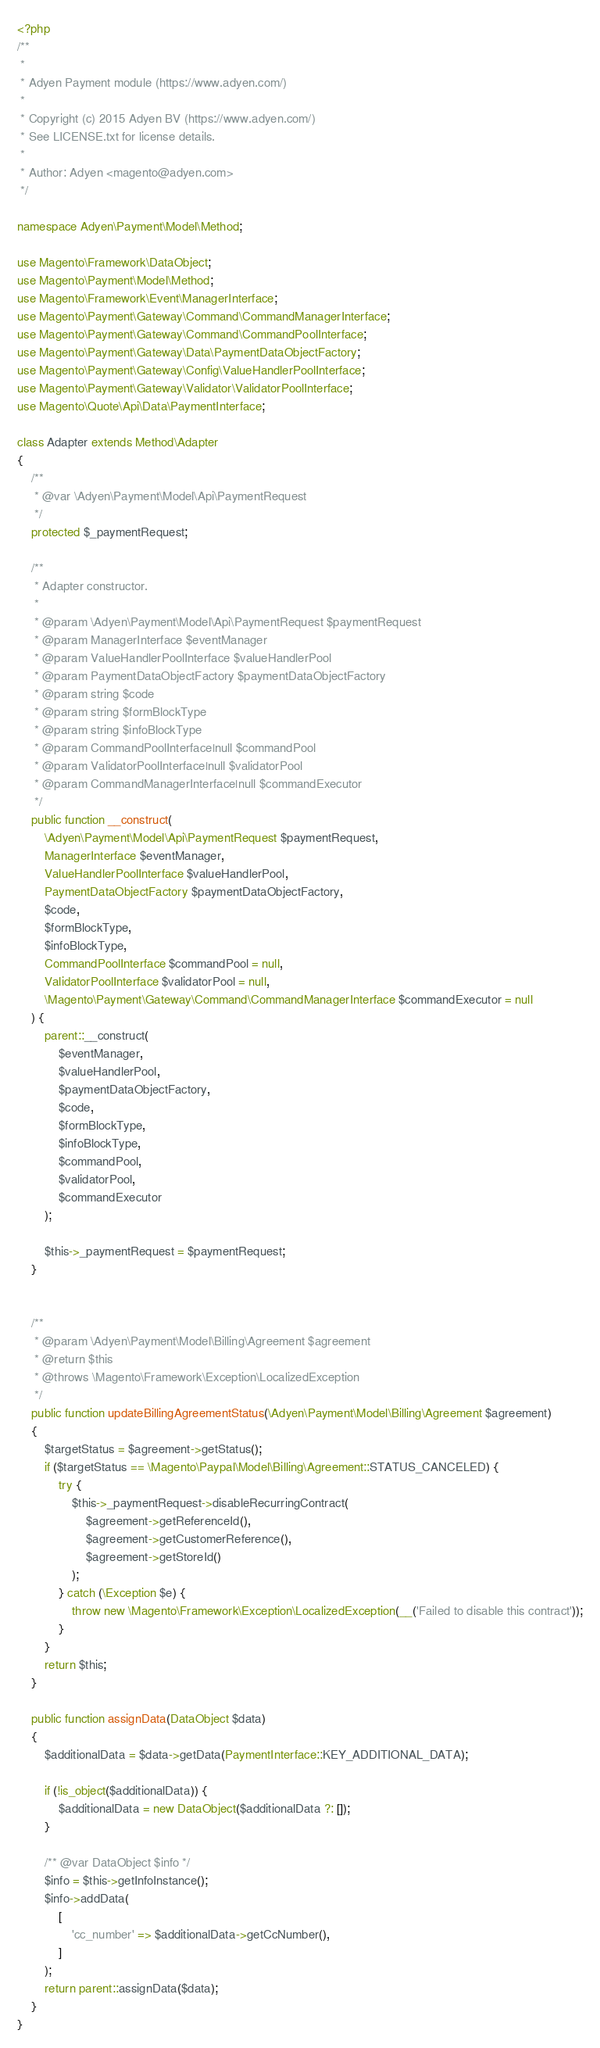Convert code to text. <code><loc_0><loc_0><loc_500><loc_500><_PHP_><?php
/**
 *
 * Adyen Payment module (https://www.adyen.com/)
 *
 * Copyright (c) 2015 Adyen BV (https://www.adyen.com/)
 * See LICENSE.txt for license details.
 *
 * Author: Adyen <magento@adyen.com>
 */

namespace Adyen\Payment\Model\Method;

use Magento\Framework\DataObject;
use Magento\Payment\Model\Method;
use Magento\Framework\Event\ManagerInterface;
use Magento\Payment\Gateway\Command\CommandManagerInterface;
use Magento\Payment\Gateway\Command\CommandPoolInterface;
use Magento\Payment\Gateway\Data\PaymentDataObjectFactory;
use Magento\Payment\Gateway\Config\ValueHandlerPoolInterface;
use Magento\Payment\Gateway\Validator\ValidatorPoolInterface;
use Magento\Quote\Api\Data\PaymentInterface;

class Adapter extends Method\Adapter
{
    /**
     * @var \Adyen\Payment\Model\Api\PaymentRequest
     */
    protected $_paymentRequest;

    /**
     * Adapter constructor.
     *
     * @param \Adyen\Payment\Model\Api\PaymentRequest $paymentRequest
     * @param ManagerInterface $eventManager
     * @param ValueHandlerPoolInterface $valueHandlerPool
     * @param PaymentDataObjectFactory $paymentDataObjectFactory
     * @param string $code
     * @param string $formBlockType
     * @param string $infoBlockType
     * @param CommandPoolInterface|null $commandPool
     * @param ValidatorPoolInterface|null $validatorPool
     * @param CommandManagerInterface|null $commandExecutor
     */
    public function __construct(
        \Adyen\Payment\Model\Api\PaymentRequest $paymentRequest,
        ManagerInterface $eventManager,
        ValueHandlerPoolInterface $valueHandlerPool,
        PaymentDataObjectFactory $paymentDataObjectFactory,
        $code,
        $formBlockType,
        $infoBlockType,
        CommandPoolInterface $commandPool = null,
        ValidatorPoolInterface $validatorPool = null,
        \Magento\Payment\Gateway\Command\CommandManagerInterface $commandExecutor = null
    ) {
        parent::__construct(
            $eventManager,
            $valueHandlerPool,
            $paymentDataObjectFactory,
            $code,
            $formBlockType,
            $infoBlockType,
            $commandPool,
            $validatorPool,
            $commandExecutor
        );

        $this->_paymentRequest = $paymentRequest;
    }


    /**
     * @param \Adyen\Payment\Model\Billing\Agreement $agreement
     * @return $this
     * @throws \Magento\Framework\Exception\LocalizedException
     */
    public function updateBillingAgreementStatus(\Adyen\Payment\Model\Billing\Agreement $agreement)
    {
        $targetStatus = $agreement->getStatus();
        if ($targetStatus == \Magento\Paypal\Model\Billing\Agreement::STATUS_CANCELED) {
            try {
                $this->_paymentRequest->disableRecurringContract(
                    $agreement->getReferenceId(),
                    $agreement->getCustomerReference(),
                    $agreement->getStoreId()
                );
            } catch (\Exception $e) {
                throw new \Magento\Framework\Exception\LocalizedException(__('Failed to disable this contract'));
            }
        }
        return $this;
    }

    public function assignData(DataObject $data)
    {
        $additionalData = $data->getData(PaymentInterface::KEY_ADDITIONAL_DATA);

        if (!is_object($additionalData)) {
            $additionalData = new DataObject($additionalData ?: []);
        }

        /** @var DataObject $info */
        $info = $this->getInfoInstance();
        $info->addData(
            [
                'cc_number' => $additionalData->getCcNumber(),
            ]
        );
        return parent::assignData($data);
    }
}
</code> 